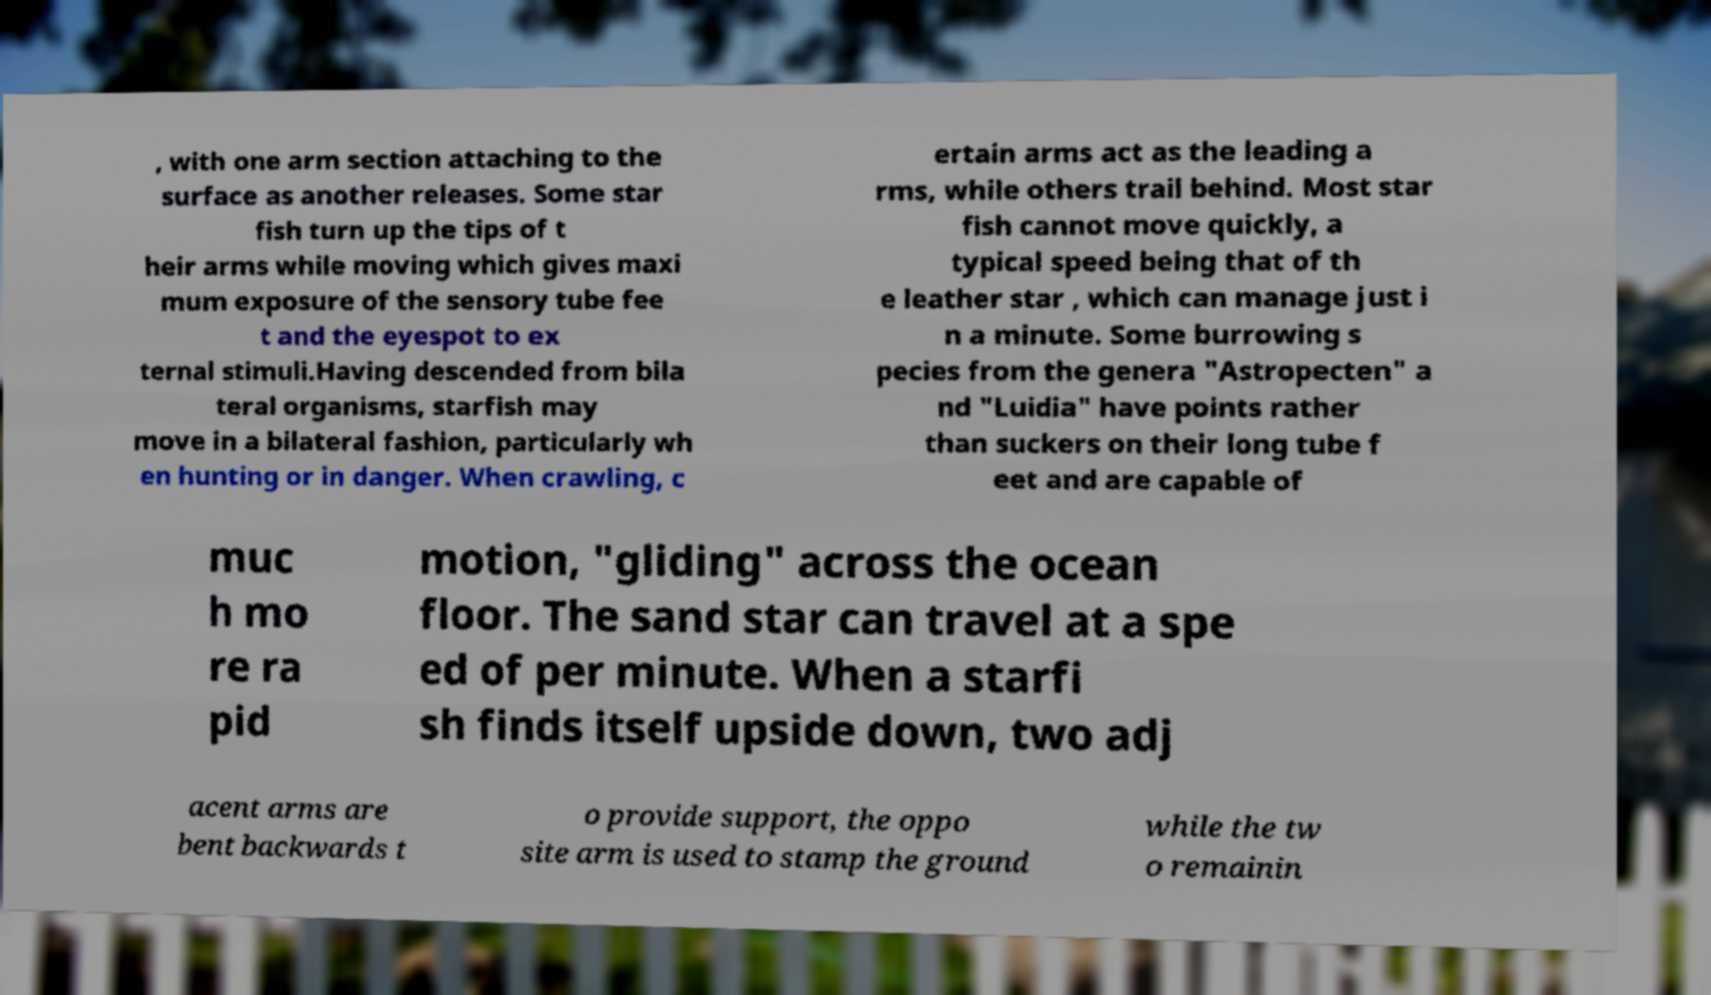Please identify and transcribe the text found in this image. , with one arm section attaching to the surface as another releases. Some star fish turn up the tips of t heir arms while moving which gives maxi mum exposure of the sensory tube fee t and the eyespot to ex ternal stimuli.Having descended from bila teral organisms, starfish may move in a bilateral fashion, particularly wh en hunting or in danger. When crawling, c ertain arms act as the leading a rms, while others trail behind. Most star fish cannot move quickly, a typical speed being that of th e leather star , which can manage just i n a minute. Some burrowing s pecies from the genera "Astropecten" a nd "Luidia" have points rather than suckers on their long tube f eet and are capable of muc h mo re ra pid motion, "gliding" across the ocean floor. The sand star can travel at a spe ed of per minute. When a starfi sh finds itself upside down, two adj acent arms are bent backwards t o provide support, the oppo site arm is used to stamp the ground while the tw o remainin 